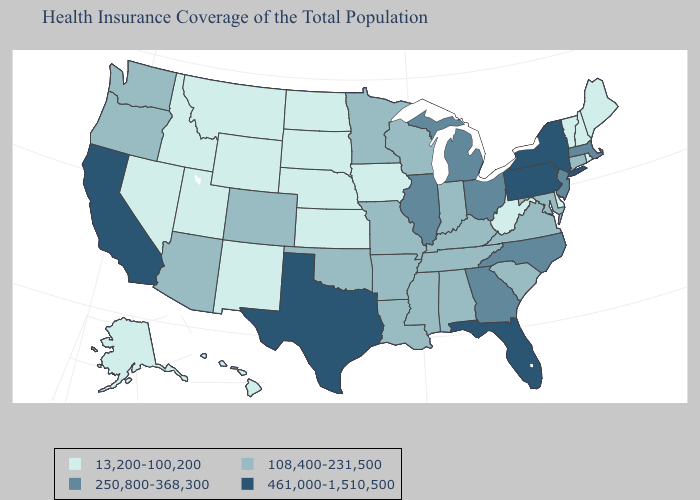What is the lowest value in the West?
Concise answer only. 13,200-100,200. Does Indiana have the highest value in the USA?
Write a very short answer. No. Is the legend a continuous bar?
Keep it brief. No. Name the states that have a value in the range 461,000-1,510,500?
Concise answer only. California, Florida, New York, Pennsylvania, Texas. Does California have the highest value in the West?
Quick response, please. Yes. What is the value of New York?
Concise answer only. 461,000-1,510,500. What is the value of Kentucky?
Answer briefly. 108,400-231,500. Does California have a lower value than Nebraska?
Short answer required. No. What is the value of Wisconsin?
Answer briefly. 108,400-231,500. What is the value of Michigan?
Quick response, please. 250,800-368,300. Does the map have missing data?
Short answer required. No. Does Virginia have a lower value than Georgia?
Concise answer only. Yes. What is the value of Delaware?
Concise answer only. 13,200-100,200. Name the states that have a value in the range 250,800-368,300?
Answer briefly. Georgia, Illinois, Massachusetts, Michigan, New Jersey, North Carolina, Ohio. What is the value of Alabama?
Write a very short answer. 108,400-231,500. 